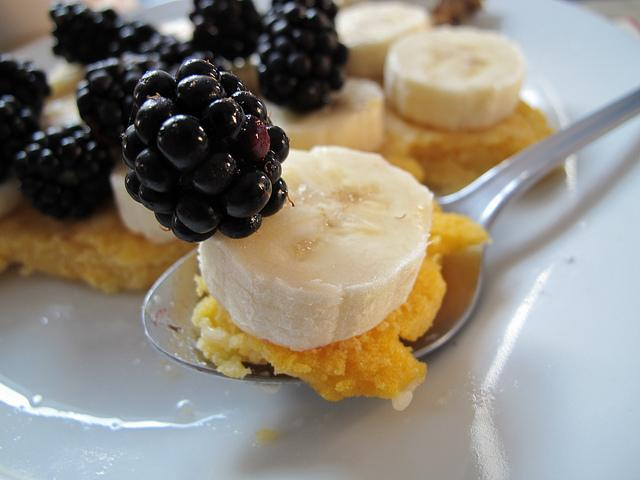What type of fruit is at the very top of the scoop with the banana and oat? Please explain your reasoning. blackberry. The berries are colored black. 